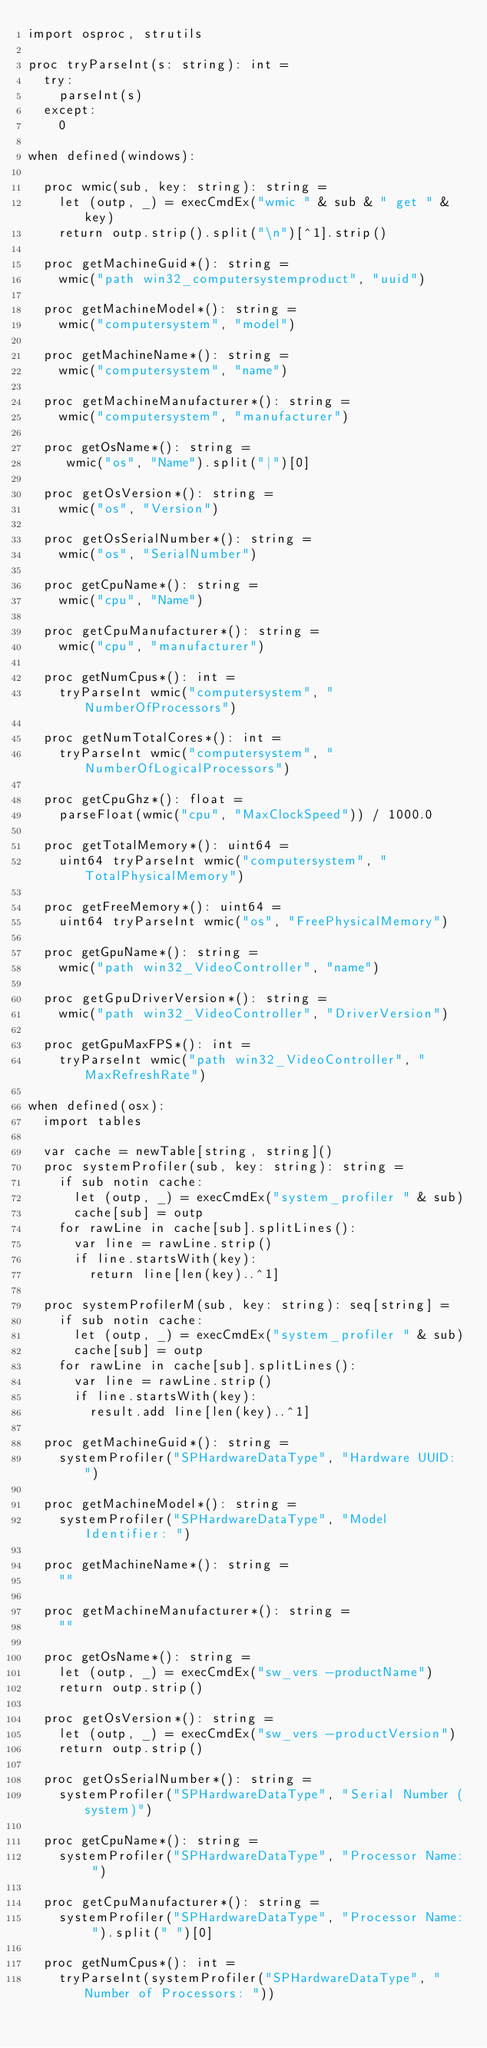<code> <loc_0><loc_0><loc_500><loc_500><_Nim_>import osproc, strutils

proc tryParseInt(s: string): int =
  try:
    parseInt(s)
  except:
    0

when defined(windows):

  proc wmic(sub, key: string): string =
    let (outp, _) = execCmdEx("wmic " & sub & " get " & key)
    return outp.strip().split("\n")[^1].strip()

  proc getMachineGuid*(): string =
    wmic("path win32_computersystemproduct", "uuid")

  proc getMachineModel*(): string =
    wmic("computersystem", "model")

  proc getMachineName*(): string =
    wmic("computersystem", "name")

  proc getMachineManufacturer*(): string =
    wmic("computersystem", "manufacturer")

  proc getOsName*(): string =
     wmic("os", "Name").split("|")[0]

  proc getOsVersion*(): string =
    wmic("os", "Version")

  proc getOsSerialNumber*(): string =
    wmic("os", "SerialNumber")

  proc getCpuName*(): string =
    wmic("cpu", "Name")

  proc getCpuManufacturer*(): string =
    wmic("cpu", "manufacturer")

  proc getNumCpus*(): int =
    tryParseInt wmic("computersystem", "NumberOfProcessors")

  proc getNumTotalCores*(): int =
    tryParseInt wmic("computersystem", "NumberOfLogicalProcessors")

  proc getCpuGhz*(): float =
    parseFloat(wmic("cpu", "MaxClockSpeed")) / 1000.0

  proc getTotalMemory*(): uint64 =
    uint64 tryParseInt wmic("computersystem", "TotalPhysicalMemory")

  proc getFreeMemory*(): uint64 =
    uint64 tryParseInt wmic("os", "FreePhysicalMemory")

  proc getGpuName*(): string =
    wmic("path win32_VideoController", "name")

  proc getGpuDriverVersion*(): string =
    wmic("path win32_VideoController", "DriverVersion")

  proc getGpuMaxFPS*(): int =
    tryParseInt wmic("path win32_VideoController", "MaxRefreshRate")

when defined(osx):
  import tables

  var cache = newTable[string, string]()
  proc systemProfiler(sub, key: string): string =
    if sub notin cache:
      let (outp, _) = execCmdEx("system_profiler " & sub)
      cache[sub] = outp
    for rawLine in cache[sub].splitLines():
      var line = rawLine.strip()
      if line.startsWith(key):
        return line[len(key)..^1]

  proc systemProfilerM(sub, key: string): seq[string] =
    if sub notin cache:
      let (outp, _) = execCmdEx("system_profiler " & sub)
      cache[sub] = outp
    for rawLine in cache[sub].splitLines():
      var line = rawLine.strip()
      if line.startsWith(key):
        result.add line[len(key)..^1]

  proc getMachineGuid*(): string =
    systemProfiler("SPHardwareDataType", "Hardware UUID: ")

  proc getMachineModel*(): string =
    systemProfiler("SPHardwareDataType", "Model Identifier: ")

  proc getMachineName*(): string =
    ""

  proc getMachineManufacturer*(): string =
    ""

  proc getOsName*(): string =
    let (outp, _) = execCmdEx("sw_vers -productName")
    return outp.strip()

  proc getOsVersion*(): string =
    let (outp, _) = execCmdEx("sw_vers -productVersion")
    return outp.strip()

  proc getOsSerialNumber*(): string =
    systemProfiler("SPHardwareDataType", "Serial Number (system)")

  proc getCpuName*(): string =
    systemProfiler("SPHardwareDataType", "Processor Name: ")

  proc getCpuManufacturer*(): string =
    systemProfiler("SPHardwareDataType", "Processor Name: ").split(" ")[0]

  proc getNumCpus*(): int =
    tryParseInt(systemProfiler("SPHardwareDataType", "Number of Processors: "))
</code> 